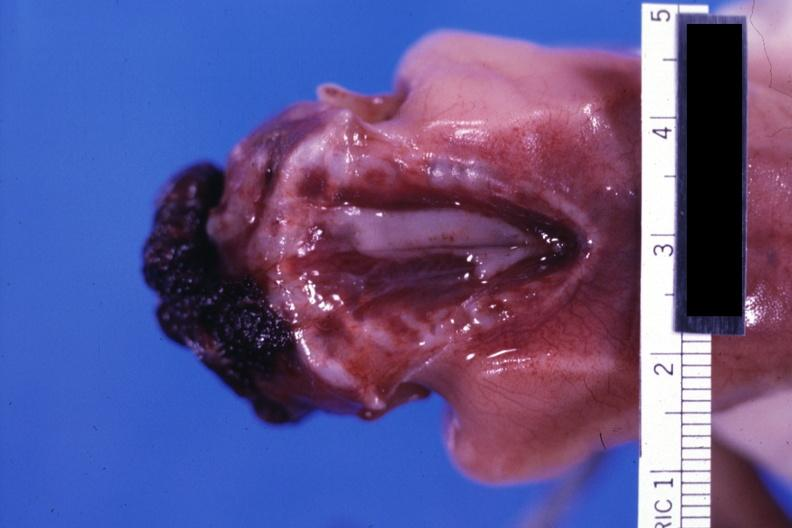s anencephaly present?
Answer the question using a single word or phrase. Yes 